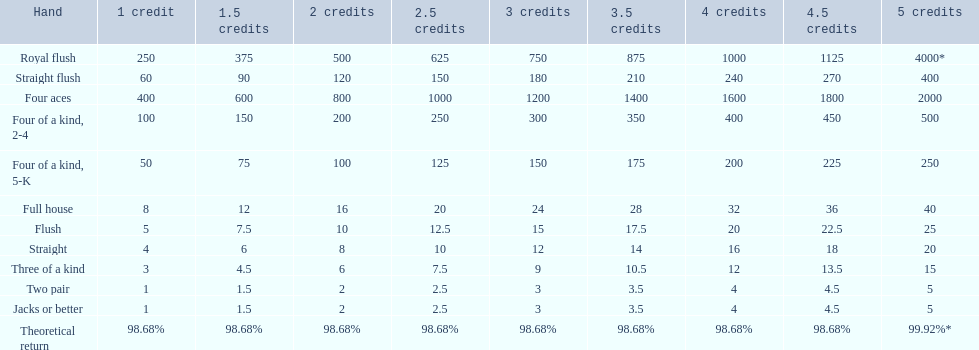What is the higher amount of points for one credit you can get from the best four of a kind 100. What type is it? Four of a kind, 2-4. 